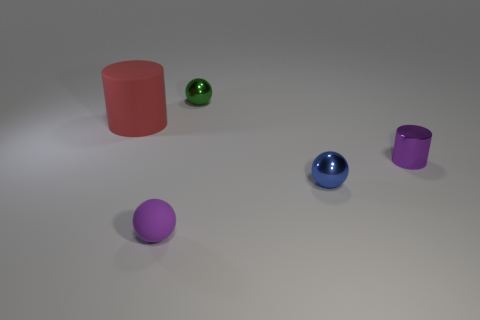Are there fewer green objects that are to the left of the green metallic thing than matte things behind the small blue metal ball?
Offer a terse response. Yes. The tiny purple object that is in front of the purple cylinder has what shape?
Offer a very short reply. Sphere. There is a tiny thing that is the same color as the rubber sphere; what is its material?
Ensure brevity in your answer.  Metal. What number of other things are there of the same material as the small green ball
Your answer should be very brief. 2. There is a green object; is it the same shape as the blue object behind the tiny matte sphere?
Make the answer very short. Yes. The thing that is the same material as the purple ball is what shape?
Offer a terse response. Cylinder. Are there more tiny blue metal spheres in front of the small green sphere than blue metal balls that are on the left side of the large rubber cylinder?
Ensure brevity in your answer.  Yes. What number of things are either red objects or tiny blue rubber cubes?
Give a very brief answer. 1. What number of other things are the same color as the large rubber object?
Give a very brief answer. 0. There is a blue metal object that is the same size as the purple rubber sphere; what shape is it?
Provide a short and direct response. Sphere. 